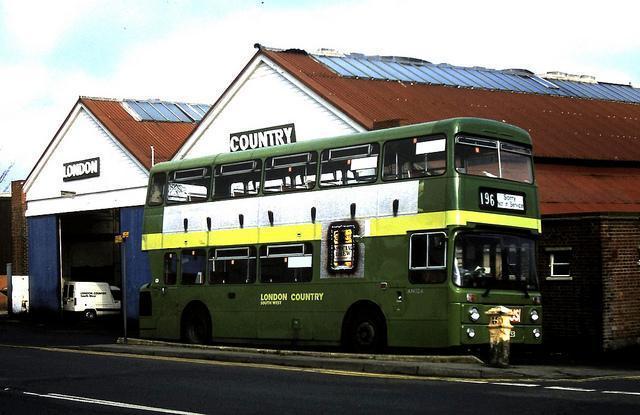How many buses are there here?
Give a very brief answer. 1. How many buses are there?
Give a very brief answer. 1. 